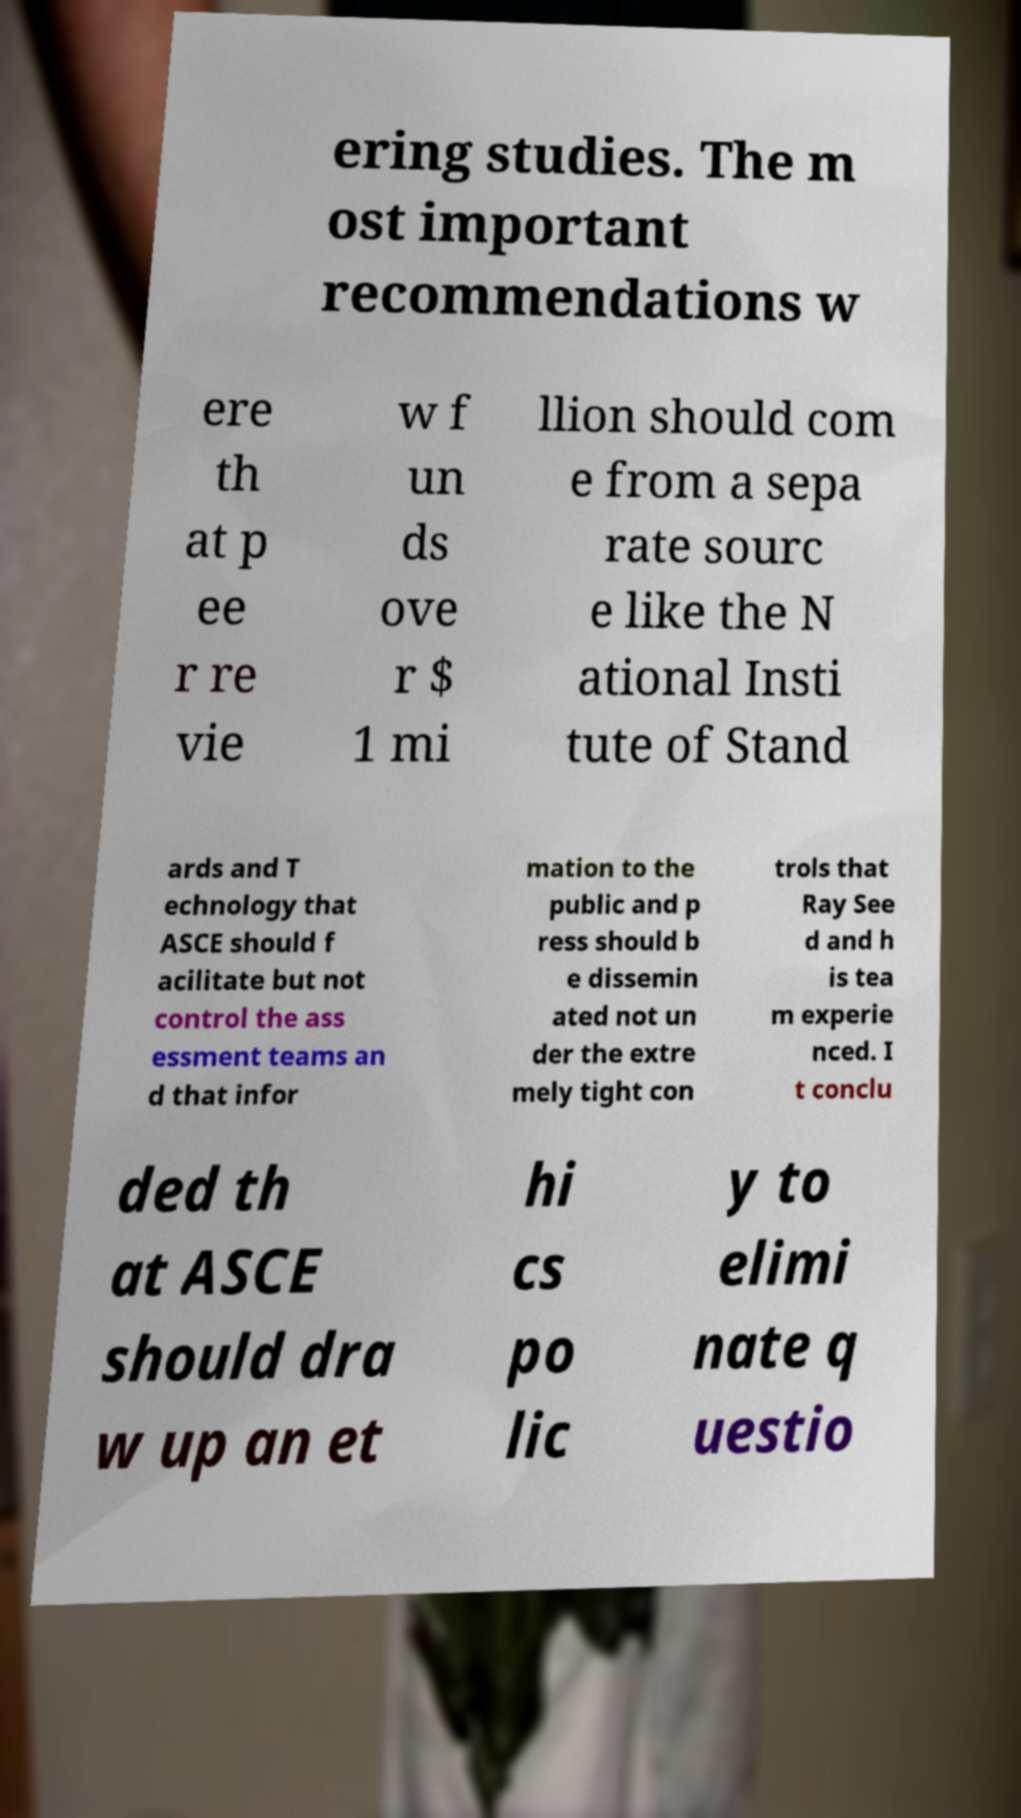Can you read and provide the text displayed in the image?This photo seems to have some interesting text. Can you extract and type it out for me? ering studies. The m ost important recommendations w ere th at p ee r re vie w f un ds ove r $ 1 mi llion should com e from a sepa rate sourc e like the N ational Insti tute of Stand ards and T echnology that ASCE should f acilitate but not control the ass essment teams an d that infor mation to the public and p ress should b e dissemin ated not un der the extre mely tight con trols that Ray See d and h is tea m experie nced. I t conclu ded th at ASCE should dra w up an et hi cs po lic y to elimi nate q uestio 